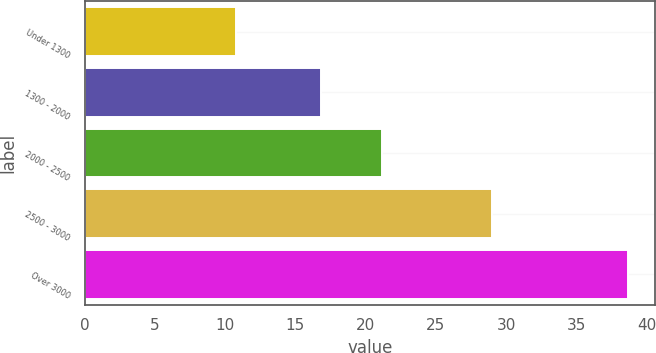Convert chart. <chart><loc_0><loc_0><loc_500><loc_500><bar_chart><fcel>Under 1300<fcel>1300 - 2000<fcel>2000 - 2500<fcel>2500 - 3000<fcel>Over 3000<nl><fcel>10.77<fcel>16.85<fcel>21.15<fcel>29.03<fcel>38.66<nl></chart> 